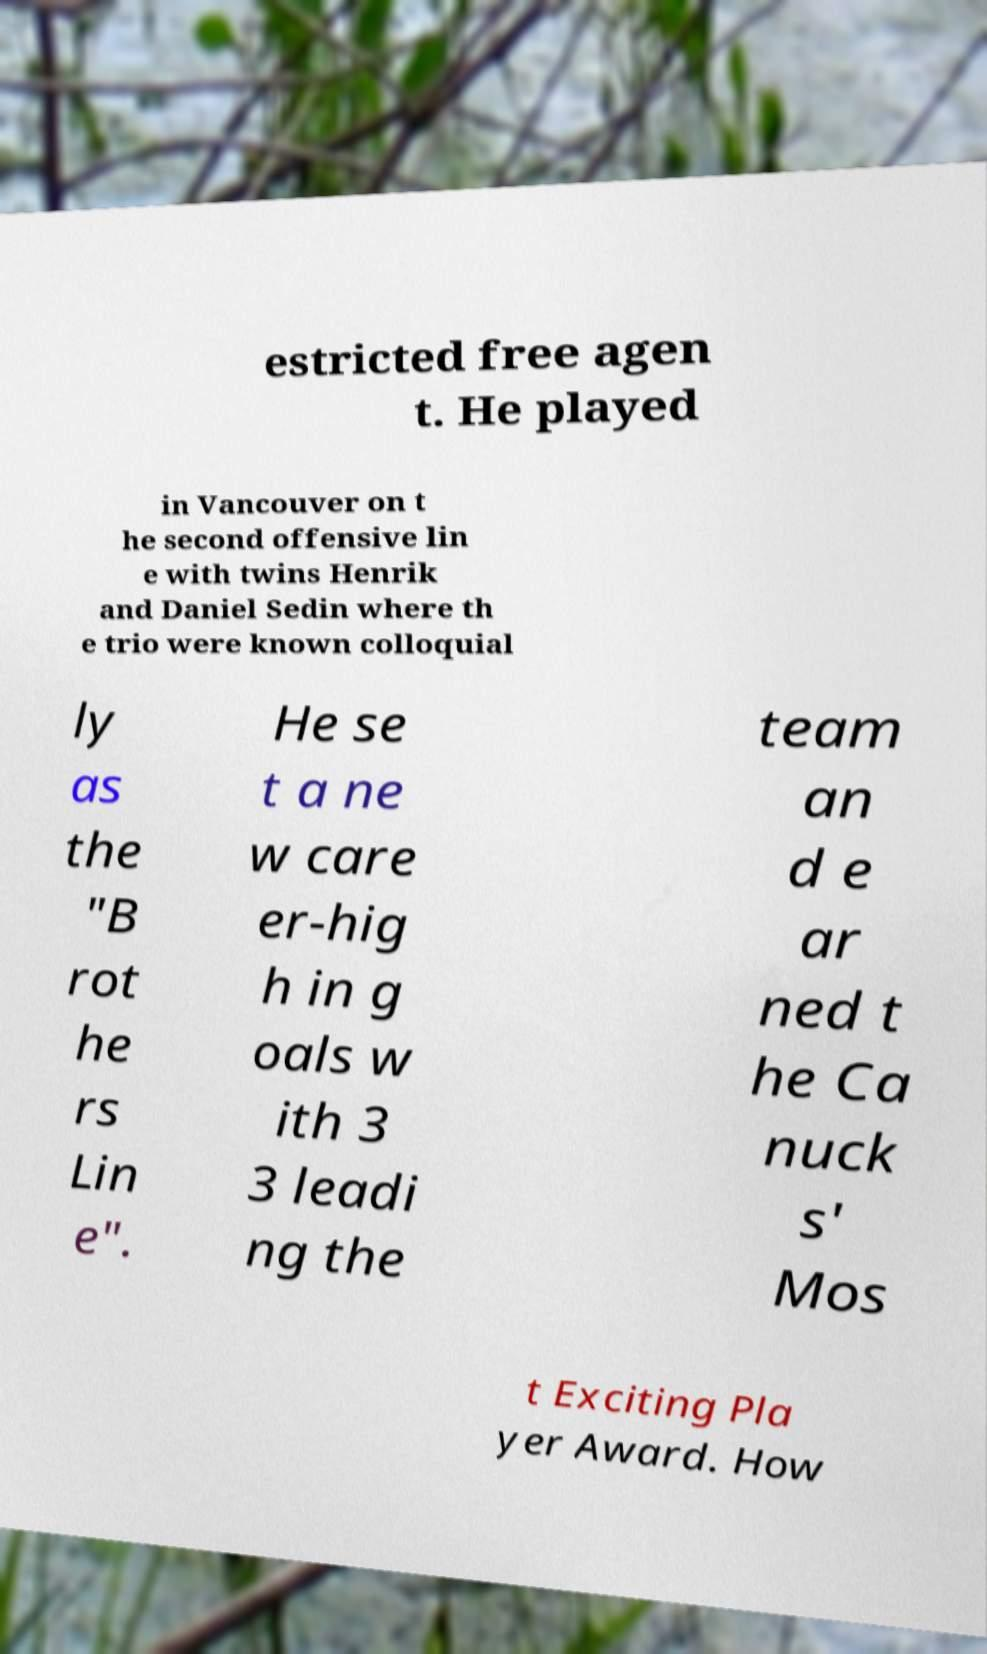For documentation purposes, I need the text within this image transcribed. Could you provide that? estricted free agen t. He played in Vancouver on t he second offensive lin e with twins Henrik and Daniel Sedin where th e trio were known colloquial ly as the "B rot he rs Lin e". He se t a ne w care er-hig h in g oals w ith 3 3 leadi ng the team an d e ar ned t he Ca nuck s' Mos t Exciting Pla yer Award. How 